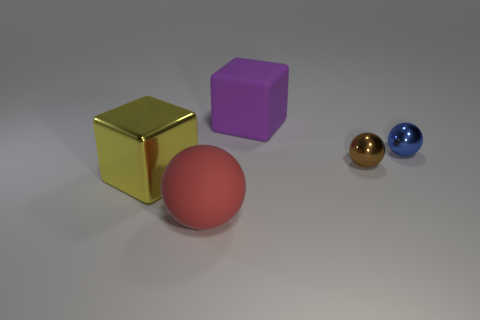Add 2 big brown blocks. How many objects exist? 7 Subtract all blocks. How many objects are left? 3 Add 4 red objects. How many red objects are left? 5 Add 4 large green matte spheres. How many large green matte spheres exist? 4 Subtract 0 brown cylinders. How many objects are left? 5 Subtract all tiny green matte spheres. Subtract all metallic spheres. How many objects are left? 3 